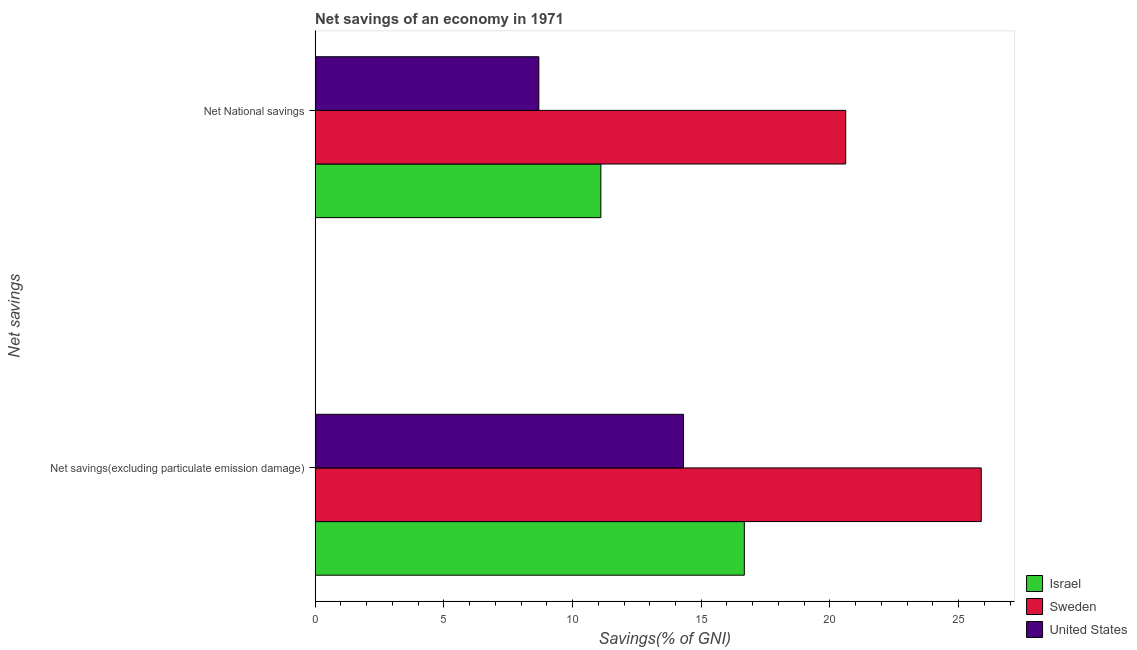How many different coloured bars are there?
Give a very brief answer. 3. Are the number of bars per tick equal to the number of legend labels?
Your answer should be very brief. Yes. How many bars are there on the 2nd tick from the bottom?
Keep it short and to the point. 3. What is the label of the 1st group of bars from the top?
Offer a terse response. Net National savings. What is the net savings(excluding particulate emission damage) in United States?
Offer a terse response. 14.31. Across all countries, what is the maximum net savings(excluding particulate emission damage)?
Your answer should be very brief. 25.88. Across all countries, what is the minimum net savings(excluding particulate emission damage)?
Your response must be concise. 14.31. In which country was the net national savings maximum?
Offer a very short reply. Sweden. In which country was the net national savings minimum?
Your answer should be very brief. United States. What is the total net national savings in the graph?
Provide a short and direct response. 40.41. What is the difference between the net national savings in Israel and that in United States?
Give a very brief answer. 2.41. What is the difference between the net national savings in Israel and the net savings(excluding particulate emission damage) in Sweden?
Provide a succinct answer. -14.78. What is the average net savings(excluding particulate emission damage) per country?
Make the answer very short. 18.95. What is the difference between the net national savings and net savings(excluding particulate emission damage) in Israel?
Your answer should be very brief. -5.57. In how many countries, is the net national savings greater than 12 %?
Ensure brevity in your answer.  1. What is the ratio of the net savings(excluding particulate emission damage) in Sweden to that in United States?
Offer a very short reply. 1.81. Is the net national savings in Sweden less than that in United States?
Provide a succinct answer. No. In how many countries, is the net savings(excluding particulate emission damage) greater than the average net savings(excluding particulate emission damage) taken over all countries?
Your answer should be compact. 1. What does the 2nd bar from the bottom in Net National savings represents?
Your response must be concise. Sweden. Are all the bars in the graph horizontal?
Provide a short and direct response. Yes. What is the difference between two consecutive major ticks on the X-axis?
Your response must be concise. 5. Are the values on the major ticks of X-axis written in scientific E-notation?
Provide a succinct answer. No. Does the graph contain any zero values?
Give a very brief answer. No. Where does the legend appear in the graph?
Provide a short and direct response. Bottom right. How are the legend labels stacked?
Ensure brevity in your answer.  Vertical. What is the title of the graph?
Provide a short and direct response. Net savings of an economy in 1971. Does "Guam" appear as one of the legend labels in the graph?
Provide a short and direct response. No. What is the label or title of the X-axis?
Keep it short and to the point. Savings(% of GNI). What is the label or title of the Y-axis?
Offer a terse response. Net savings. What is the Savings(% of GNI) in Israel in Net savings(excluding particulate emission damage)?
Offer a very short reply. 16.67. What is the Savings(% of GNI) of Sweden in Net savings(excluding particulate emission damage)?
Your answer should be very brief. 25.88. What is the Savings(% of GNI) of United States in Net savings(excluding particulate emission damage)?
Keep it short and to the point. 14.31. What is the Savings(% of GNI) of Israel in Net National savings?
Keep it short and to the point. 11.1. What is the Savings(% of GNI) in Sweden in Net National savings?
Give a very brief answer. 20.61. What is the Savings(% of GNI) of United States in Net National savings?
Ensure brevity in your answer.  8.69. Across all Net savings, what is the maximum Savings(% of GNI) in Israel?
Keep it short and to the point. 16.67. Across all Net savings, what is the maximum Savings(% of GNI) of Sweden?
Make the answer very short. 25.88. Across all Net savings, what is the maximum Savings(% of GNI) in United States?
Offer a terse response. 14.31. Across all Net savings, what is the minimum Savings(% of GNI) in Israel?
Your answer should be very brief. 11.1. Across all Net savings, what is the minimum Savings(% of GNI) of Sweden?
Your answer should be very brief. 20.61. Across all Net savings, what is the minimum Savings(% of GNI) of United States?
Your answer should be very brief. 8.69. What is the total Savings(% of GNI) in Israel in the graph?
Your response must be concise. 27.78. What is the total Savings(% of GNI) of Sweden in the graph?
Give a very brief answer. 46.49. What is the total Savings(% of GNI) in United States in the graph?
Keep it short and to the point. 23. What is the difference between the Savings(% of GNI) in Israel in Net savings(excluding particulate emission damage) and that in Net National savings?
Give a very brief answer. 5.57. What is the difference between the Savings(% of GNI) in Sweden in Net savings(excluding particulate emission damage) and that in Net National savings?
Your response must be concise. 5.27. What is the difference between the Savings(% of GNI) in United States in Net savings(excluding particulate emission damage) and that in Net National savings?
Make the answer very short. 5.62. What is the difference between the Savings(% of GNI) of Israel in Net savings(excluding particulate emission damage) and the Savings(% of GNI) of Sweden in Net National savings?
Your answer should be compact. -3.94. What is the difference between the Savings(% of GNI) in Israel in Net savings(excluding particulate emission damage) and the Savings(% of GNI) in United States in Net National savings?
Your answer should be compact. 7.98. What is the difference between the Savings(% of GNI) of Sweden in Net savings(excluding particulate emission damage) and the Savings(% of GNI) of United States in Net National savings?
Offer a very short reply. 17.19. What is the average Savings(% of GNI) in Israel per Net savings?
Offer a terse response. 13.89. What is the average Savings(% of GNI) of Sweden per Net savings?
Make the answer very short. 23.25. What is the average Savings(% of GNI) in United States per Net savings?
Offer a terse response. 11.5. What is the difference between the Savings(% of GNI) in Israel and Savings(% of GNI) in Sweden in Net savings(excluding particulate emission damage)?
Your answer should be very brief. -9.2. What is the difference between the Savings(% of GNI) of Israel and Savings(% of GNI) of United States in Net savings(excluding particulate emission damage)?
Your response must be concise. 2.36. What is the difference between the Savings(% of GNI) of Sweden and Savings(% of GNI) of United States in Net savings(excluding particulate emission damage)?
Offer a very short reply. 11.57. What is the difference between the Savings(% of GNI) in Israel and Savings(% of GNI) in Sweden in Net National savings?
Ensure brevity in your answer.  -9.51. What is the difference between the Savings(% of GNI) of Israel and Savings(% of GNI) of United States in Net National savings?
Your response must be concise. 2.41. What is the difference between the Savings(% of GNI) in Sweden and Savings(% of GNI) in United States in Net National savings?
Your answer should be very brief. 11.92. What is the ratio of the Savings(% of GNI) of Israel in Net savings(excluding particulate emission damage) to that in Net National savings?
Your response must be concise. 1.5. What is the ratio of the Savings(% of GNI) of Sweden in Net savings(excluding particulate emission damage) to that in Net National savings?
Keep it short and to the point. 1.26. What is the ratio of the Savings(% of GNI) of United States in Net savings(excluding particulate emission damage) to that in Net National savings?
Your response must be concise. 1.65. What is the difference between the highest and the second highest Savings(% of GNI) of Israel?
Offer a very short reply. 5.57. What is the difference between the highest and the second highest Savings(% of GNI) of Sweden?
Make the answer very short. 5.27. What is the difference between the highest and the second highest Savings(% of GNI) of United States?
Provide a succinct answer. 5.62. What is the difference between the highest and the lowest Savings(% of GNI) in Israel?
Keep it short and to the point. 5.57. What is the difference between the highest and the lowest Savings(% of GNI) of Sweden?
Give a very brief answer. 5.27. What is the difference between the highest and the lowest Savings(% of GNI) of United States?
Keep it short and to the point. 5.62. 